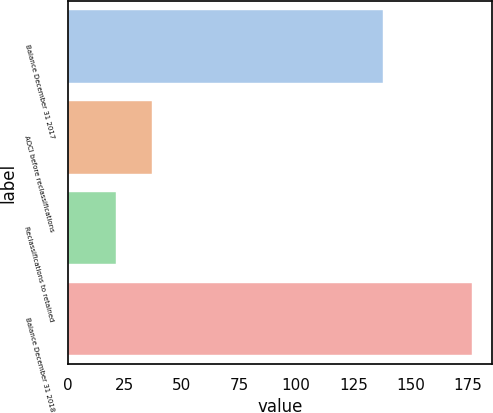<chart> <loc_0><loc_0><loc_500><loc_500><bar_chart><fcel>Balance December 31 2017<fcel>AOCI before reclassifications<fcel>Reclassifications to retained<fcel>Balance December 31 2018<nl><fcel>138.2<fcel>36.69<fcel>21.1<fcel>177<nl></chart> 